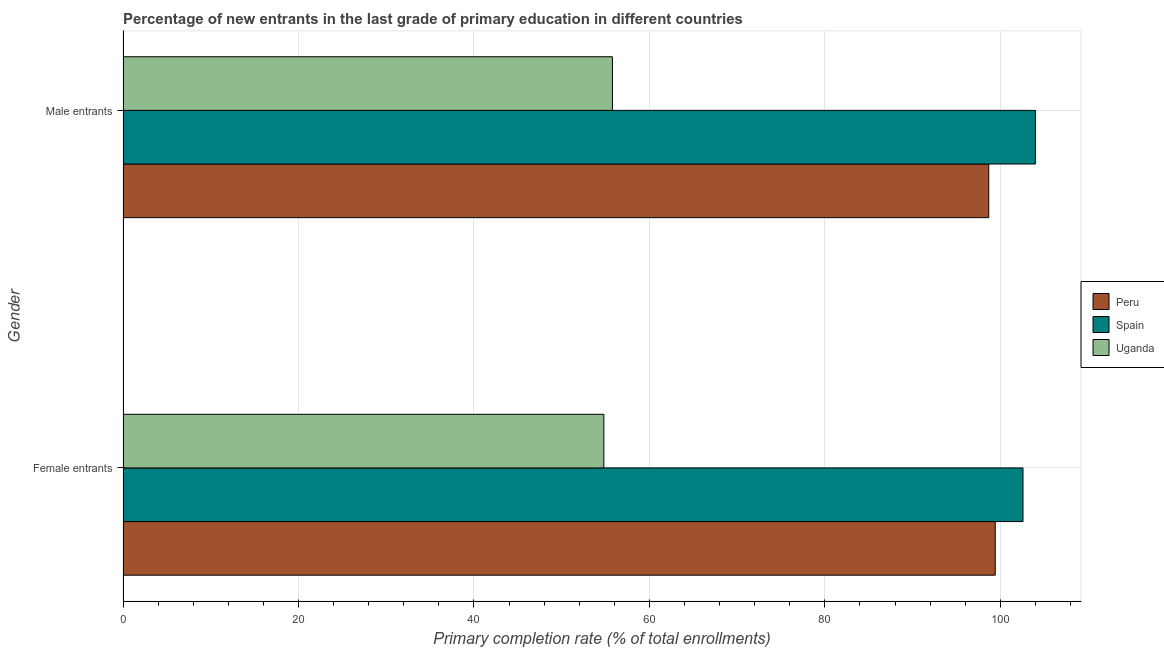How many different coloured bars are there?
Give a very brief answer. 3. How many groups of bars are there?
Give a very brief answer. 2. Are the number of bars per tick equal to the number of legend labels?
Provide a short and direct response. Yes. How many bars are there on the 1st tick from the top?
Give a very brief answer. 3. How many bars are there on the 2nd tick from the bottom?
Provide a short and direct response. 3. What is the label of the 1st group of bars from the top?
Your answer should be compact. Male entrants. What is the primary completion rate of male entrants in Uganda?
Make the answer very short. 55.79. Across all countries, what is the maximum primary completion rate of female entrants?
Your answer should be very brief. 102.59. Across all countries, what is the minimum primary completion rate of male entrants?
Keep it short and to the point. 55.79. In which country was the primary completion rate of female entrants maximum?
Give a very brief answer. Spain. In which country was the primary completion rate of female entrants minimum?
Your answer should be very brief. Uganda. What is the total primary completion rate of female entrants in the graph?
Your answer should be very brief. 256.81. What is the difference between the primary completion rate of female entrants in Uganda and that in Spain?
Your answer should be compact. -47.78. What is the difference between the primary completion rate of male entrants in Spain and the primary completion rate of female entrants in Uganda?
Your answer should be very brief. 49.19. What is the average primary completion rate of female entrants per country?
Your answer should be very brief. 85.6. What is the difference between the primary completion rate of male entrants and primary completion rate of female entrants in Spain?
Keep it short and to the point. 1.41. What is the ratio of the primary completion rate of female entrants in Spain to that in Peru?
Your answer should be very brief. 1.03. Is the primary completion rate of female entrants in Spain less than that in Uganda?
Keep it short and to the point. No. What does the 1st bar from the top in Male entrants represents?
Make the answer very short. Uganda. What does the 2nd bar from the bottom in Male entrants represents?
Give a very brief answer. Spain. What is the difference between two consecutive major ticks on the X-axis?
Offer a very short reply. 20. Does the graph contain any zero values?
Make the answer very short. No. Does the graph contain grids?
Your answer should be very brief. Yes. How are the legend labels stacked?
Ensure brevity in your answer.  Vertical. What is the title of the graph?
Provide a succinct answer. Percentage of new entrants in the last grade of primary education in different countries. Does "Swaziland" appear as one of the legend labels in the graph?
Ensure brevity in your answer.  No. What is the label or title of the X-axis?
Your answer should be very brief. Primary completion rate (% of total enrollments). What is the label or title of the Y-axis?
Your response must be concise. Gender. What is the Primary completion rate (% of total enrollments) in Peru in Female entrants?
Give a very brief answer. 99.42. What is the Primary completion rate (% of total enrollments) of Spain in Female entrants?
Offer a very short reply. 102.59. What is the Primary completion rate (% of total enrollments) of Uganda in Female entrants?
Make the answer very short. 54.81. What is the Primary completion rate (% of total enrollments) in Peru in Male entrants?
Give a very brief answer. 98.68. What is the Primary completion rate (% of total enrollments) of Spain in Male entrants?
Ensure brevity in your answer.  104. What is the Primary completion rate (% of total enrollments) of Uganda in Male entrants?
Offer a very short reply. 55.79. Across all Gender, what is the maximum Primary completion rate (% of total enrollments) in Peru?
Make the answer very short. 99.42. Across all Gender, what is the maximum Primary completion rate (% of total enrollments) of Spain?
Provide a short and direct response. 104. Across all Gender, what is the maximum Primary completion rate (% of total enrollments) in Uganda?
Keep it short and to the point. 55.79. Across all Gender, what is the minimum Primary completion rate (% of total enrollments) of Peru?
Give a very brief answer. 98.68. Across all Gender, what is the minimum Primary completion rate (% of total enrollments) in Spain?
Your response must be concise. 102.59. Across all Gender, what is the minimum Primary completion rate (% of total enrollments) of Uganda?
Your response must be concise. 54.81. What is the total Primary completion rate (% of total enrollments) of Peru in the graph?
Ensure brevity in your answer.  198.1. What is the total Primary completion rate (% of total enrollments) in Spain in the graph?
Your answer should be compact. 206.58. What is the total Primary completion rate (% of total enrollments) in Uganda in the graph?
Give a very brief answer. 110.59. What is the difference between the Primary completion rate (% of total enrollments) in Peru in Female entrants and that in Male entrants?
Your answer should be very brief. 0.74. What is the difference between the Primary completion rate (% of total enrollments) in Spain in Female entrants and that in Male entrants?
Offer a very short reply. -1.41. What is the difference between the Primary completion rate (% of total enrollments) of Uganda in Female entrants and that in Male entrants?
Ensure brevity in your answer.  -0.98. What is the difference between the Primary completion rate (% of total enrollments) in Peru in Female entrants and the Primary completion rate (% of total enrollments) in Spain in Male entrants?
Your response must be concise. -4.58. What is the difference between the Primary completion rate (% of total enrollments) in Peru in Female entrants and the Primary completion rate (% of total enrollments) in Uganda in Male entrants?
Your answer should be very brief. 43.63. What is the difference between the Primary completion rate (% of total enrollments) in Spain in Female entrants and the Primary completion rate (% of total enrollments) in Uganda in Male entrants?
Keep it short and to the point. 46.8. What is the average Primary completion rate (% of total enrollments) in Peru per Gender?
Give a very brief answer. 99.05. What is the average Primary completion rate (% of total enrollments) of Spain per Gender?
Provide a succinct answer. 103.29. What is the average Primary completion rate (% of total enrollments) in Uganda per Gender?
Your answer should be compact. 55.3. What is the difference between the Primary completion rate (% of total enrollments) in Peru and Primary completion rate (% of total enrollments) in Spain in Female entrants?
Ensure brevity in your answer.  -3.16. What is the difference between the Primary completion rate (% of total enrollments) in Peru and Primary completion rate (% of total enrollments) in Uganda in Female entrants?
Ensure brevity in your answer.  44.61. What is the difference between the Primary completion rate (% of total enrollments) of Spain and Primary completion rate (% of total enrollments) of Uganda in Female entrants?
Give a very brief answer. 47.78. What is the difference between the Primary completion rate (% of total enrollments) of Peru and Primary completion rate (% of total enrollments) of Spain in Male entrants?
Provide a short and direct response. -5.32. What is the difference between the Primary completion rate (% of total enrollments) in Peru and Primary completion rate (% of total enrollments) in Uganda in Male entrants?
Your answer should be very brief. 42.9. What is the difference between the Primary completion rate (% of total enrollments) in Spain and Primary completion rate (% of total enrollments) in Uganda in Male entrants?
Offer a terse response. 48.21. What is the ratio of the Primary completion rate (% of total enrollments) in Peru in Female entrants to that in Male entrants?
Ensure brevity in your answer.  1.01. What is the ratio of the Primary completion rate (% of total enrollments) in Spain in Female entrants to that in Male entrants?
Make the answer very short. 0.99. What is the ratio of the Primary completion rate (% of total enrollments) in Uganda in Female entrants to that in Male entrants?
Offer a very short reply. 0.98. What is the difference between the highest and the second highest Primary completion rate (% of total enrollments) in Peru?
Your response must be concise. 0.74. What is the difference between the highest and the second highest Primary completion rate (% of total enrollments) in Spain?
Provide a succinct answer. 1.41. What is the difference between the highest and the second highest Primary completion rate (% of total enrollments) of Uganda?
Your answer should be very brief. 0.98. What is the difference between the highest and the lowest Primary completion rate (% of total enrollments) of Peru?
Provide a succinct answer. 0.74. What is the difference between the highest and the lowest Primary completion rate (% of total enrollments) of Spain?
Provide a succinct answer. 1.41. What is the difference between the highest and the lowest Primary completion rate (% of total enrollments) of Uganda?
Ensure brevity in your answer.  0.98. 